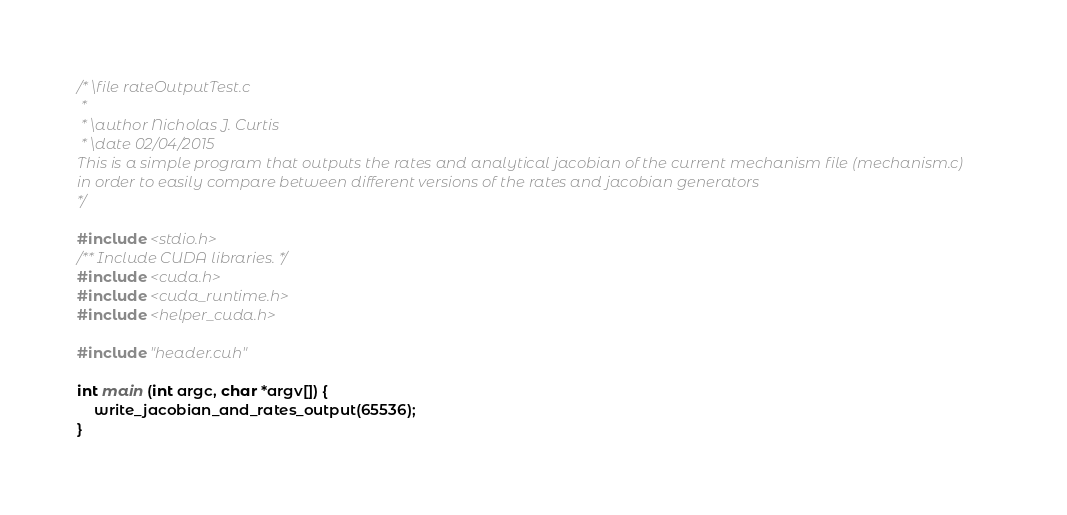<code> <loc_0><loc_0><loc_500><loc_500><_Cuda_>/* \file rateOutputTest.c
 *
 * \author Nicholas J. Curtis
 * \date 02/04/2015
This is a simple program that outputs the rates and analytical jacobian of the current mechanism file (mechanism.c)
in order to easily compare between different versions of the rates and jacobian generators
*/

#include <stdio.h>
/** Include CUDA libraries. */
#include <cuda.h>
#include <cuda_runtime.h>
#include <helper_cuda.h>

#include "header.cuh"

int main (int argc, char *argv[]) {
	write_jacobian_and_rates_output(65536);
}</code> 